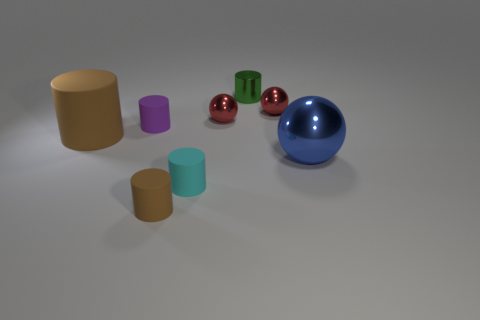Subtract all cyan cylinders. How many cylinders are left? 4 Subtract all tiny green metal cylinders. How many cylinders are left? 4 Subtract all gray cylinders. Subtract all purple blocks. How many cylinders are left? 5 Add 1 matte cylinders. How many objects exist? 9 Subtract all cylinders. How many objects are left? 3 Add 4 red rubber objects. How many red rubber objects exist? 4 Subtract 0 gray cylinders. How many objects are left? 8 Subtract all tiny purple spheres. Subtract all large blue spheres. How many objects are left? 7 Add 6 brown cylinders. How many brown cylinders are left? 8 